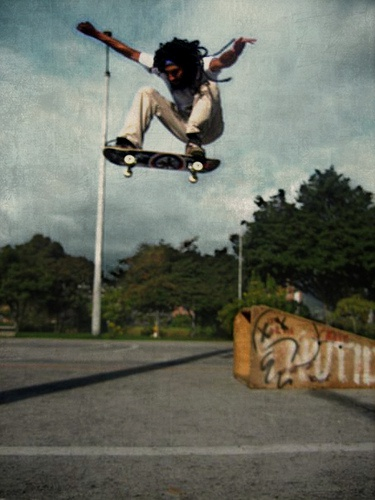Describe the objects in this image and their specific colors. I can see people in teal, black, gray, and lightgray tones and skateboard in teal, black, darkgray, gray, and beige tones in this image. 